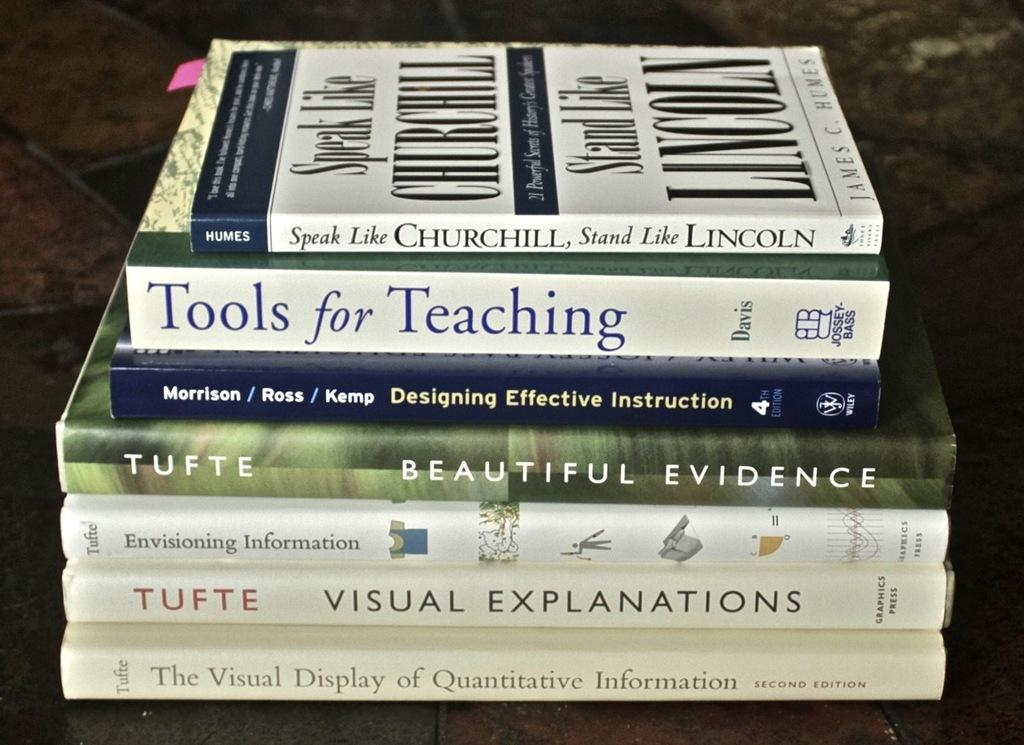<image>
Provide a brief description of the given image. a couple books used for learning and understanding different aspects of life 